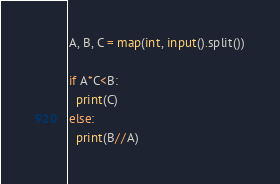Convert code to text. <code><loc_0><loc_0><loc_500><loc_500><_Python_>A, B, C = map(int, input().split())

if A*C<B:
  print(C)
else:
  print(B//A)</code> 